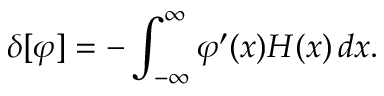Convert formula to latex. <formula><loc_0><loc_0><loc_500><loc_500>\delta [ \varphi ] = - \int _ { - \infty } ^ { \infty } \varphi ^ { \prime } ( x ) H ( x ) \, d x .</formula> 